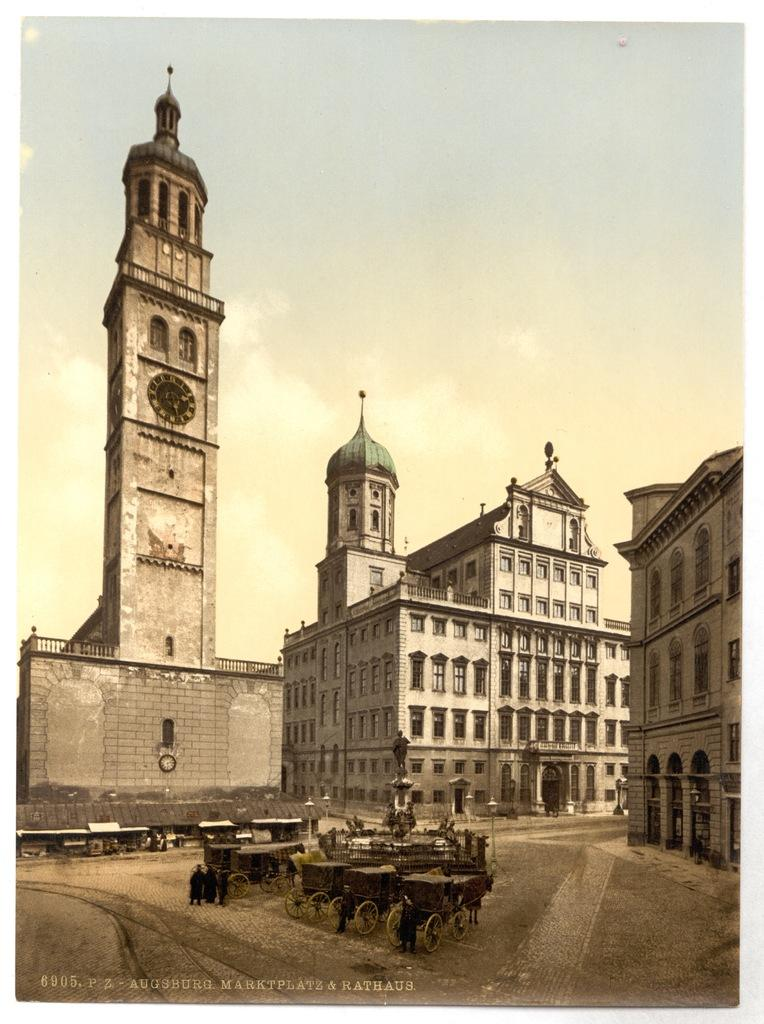What is the color scheme of the image? The image is black and white. What can be seen in the middle of the road in the image? There are horse carts in the middle of the road. What is visible in the background of the image? There are buildings, a sculpture, light poles, and the sky visible in the background. What type of sticks are being used to create the island in the image? There is no island present in the image, and therefore no sticks are being used to create it. What does the caption say about the sculpture in the image? There is no caption present in the image, so we cannot determine what it says about the sculpture. 